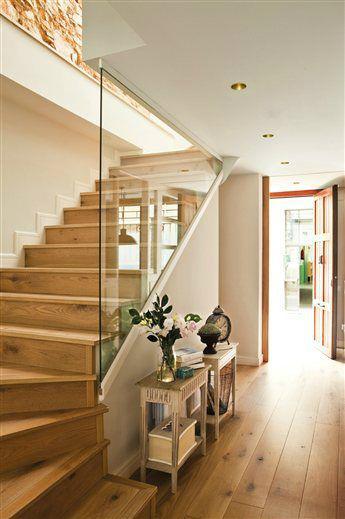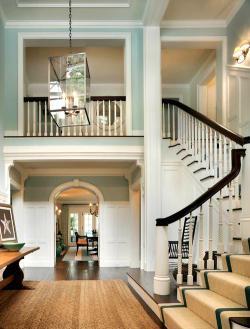The first image is the image on the left, the second image is the image on the right. Evaluate the accuracy of this statement regarding the images: "At least one of the lights is a pendant-style light hanging from the ceiling.". Is it true? Answer yes or no. Yes. The first image is the image on the left, the second image is the image on the right. Assess this claim about the two images: "There are 6 stairs point forward right with wooden rail and multiple black metal rods.". Correct or not? Answer yes or no. No. 